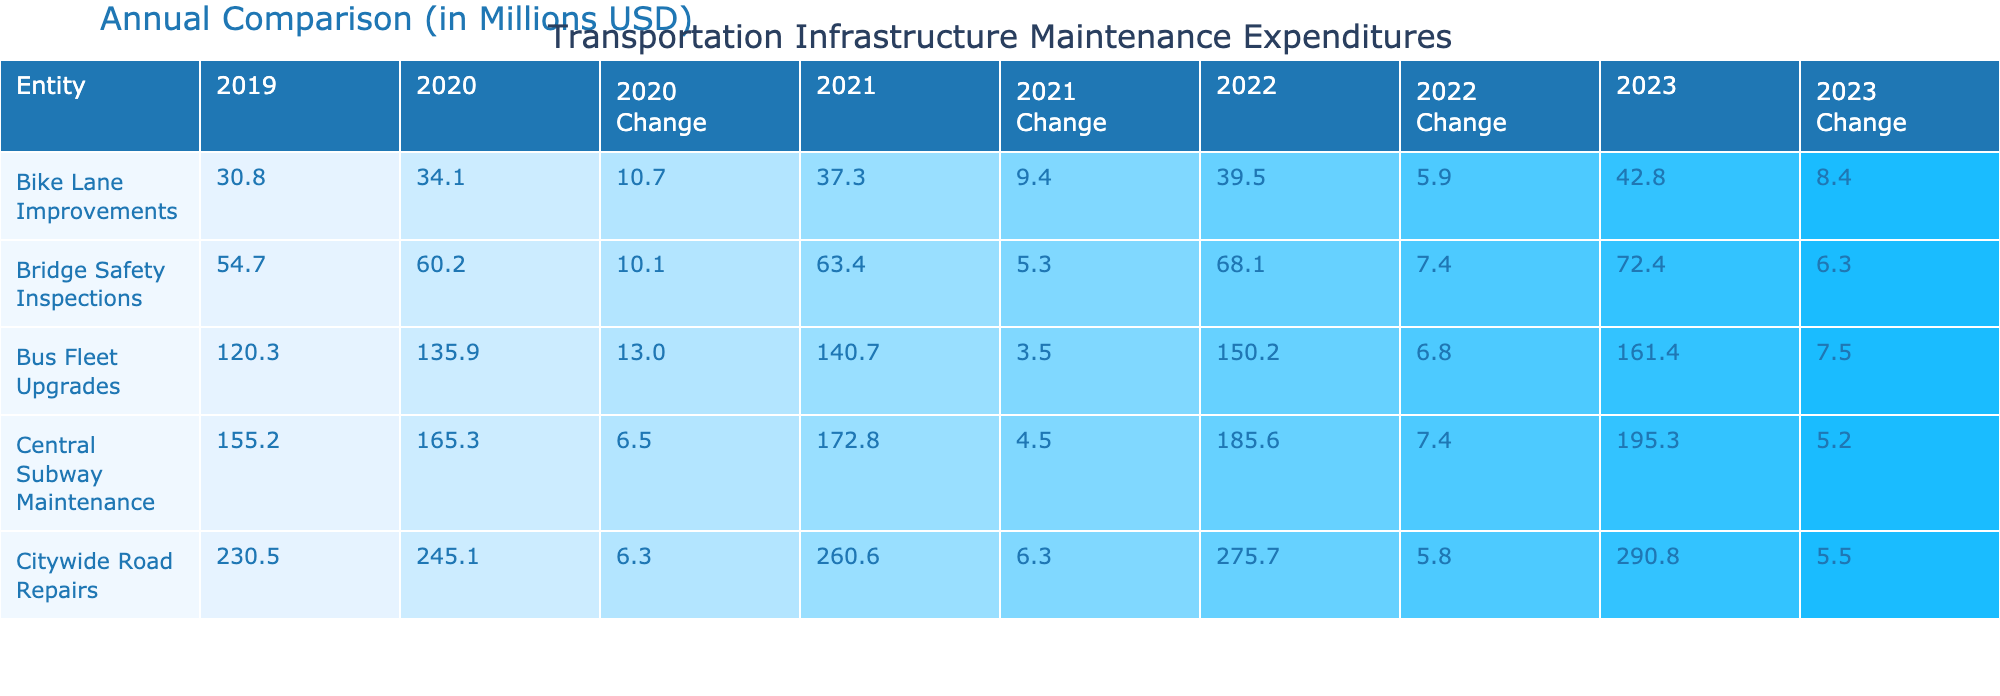What were the total expenditures for Citywide Road Repairs in 2021? According to the table, the expenditures for Citywide Road Repairs in 2021 were 260.6 million USD, directly taken from the corresponding cell for that entity and year.
Answer: 260.6 million USD Which entity had the highest expenditures in 2022? By reviewing the expenditures for each entity in 2022, Central Subway Maintenance had 185.6 million USD, Citywide Road Repairs had 275.7 million USD, Bridge Safety Inspections had 68.1 million USD, Bus Fleet Upgrades had 150.2 million USD, and Bike Lane Improvements had 39.5 million USD. The highest value is 275.7 million USD for Citywide Road Repairs.
Answer: Citywide Road Repairs Did Bus Fleet Upgrades expenditures increase every year from 2019 to 2023? Looking at the expenditures for Bus Fleet Upgrades from the table: 120.3 (2019), 135.9 (2020), 140.7 (2021), 150.2 (2022), and 161.4 (2023). Each year shows an increase from the previous year. Hence, yes, the expenditures increased every year.
Answer: Yes What is the average expenditure for Bridge Safety Inspections from 2019 to 2023? The expenditures for Bridge Safety Inspections are: 54.7 (2019), 60.2 (2020), 63.4 (2021), 68.1 (2022), and 72.4 (2023). First, we sum these values: 54.7 + 60.2 + 63.4 + 68.1 + 72.4 = 318.8 million USD. Then, we divide by the number of years (5): 318.8 / 5 = 63.76 million USD.
Answer: 63.76 million USD What was the trend in Bike Lane Improvements expenditures over the years? Examining the values: 30.8 (2019), 34.1 (2020), 37.3 (2021), 39.5 (2022), and 42.8 (2023), each shows an increase from the previous year: 30.8 to 34.1 is an increase, from 34.1 to 37.3 is again an increase, and so on. Therefore, the trend shows a consistent increase over the years.
Answer: Increasing each year What is the expenditure change for Citywide Road Repairs from 2020 to 2021? The expenditure for Citywide Road Repairs in 2020 was 245.1 million USD and in 2021 was 260.6 million USD. To determine the change, we calculate: (260.6 - 245.1) / 245.1 * 100 = approximately 6.0%. Thus, there was a 6.0% increase in expenditures.
Answer: 6.0% increase 